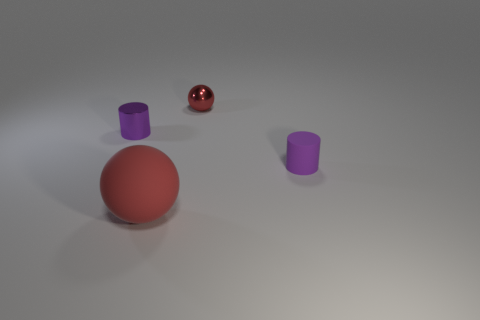There is a thing that is both in front of the shiny ball and to the right of the large rubber sphere; what size is it?
Keep it short and to the point. Small. What number of brown things are the same size as the metal ball?
Provide a short and direct response. 0. What material is the object that is the same color as the large rubber sphere?
Make the answer very short. Metal. Do the object to the right of the metal sphere and the tiny red thing have the same shape?
Your response must be concise. No. Are there fewer big red rubber balls behind the small matte thing than tiny blue metallic blocks?
Your answer should be very brief. No. Are there any other cylinders of the same color as the matte cylinder?
Your answer should be compact. Yes. Do the tiny red metallic thing and the red object that is in front of the small matte cylinder have the same shape?
Ensure brevity in your answer.  Yes. Is there a small purple object made of the same material as the tiny red thing?
Offer a very short reply. Yes. There is a small cylinder that is on the left side of the tiny metal object that is behind the purple metallic cylinder; are there any small purple cylinders that are to the right of it?
Make the answer very short. Yes. How many other things are the same shape as the large matte thing?
Keep it short and to the point. 1. 